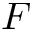<formula> <loc_0><loc_0><loc_500><loc_500>F</formula> 